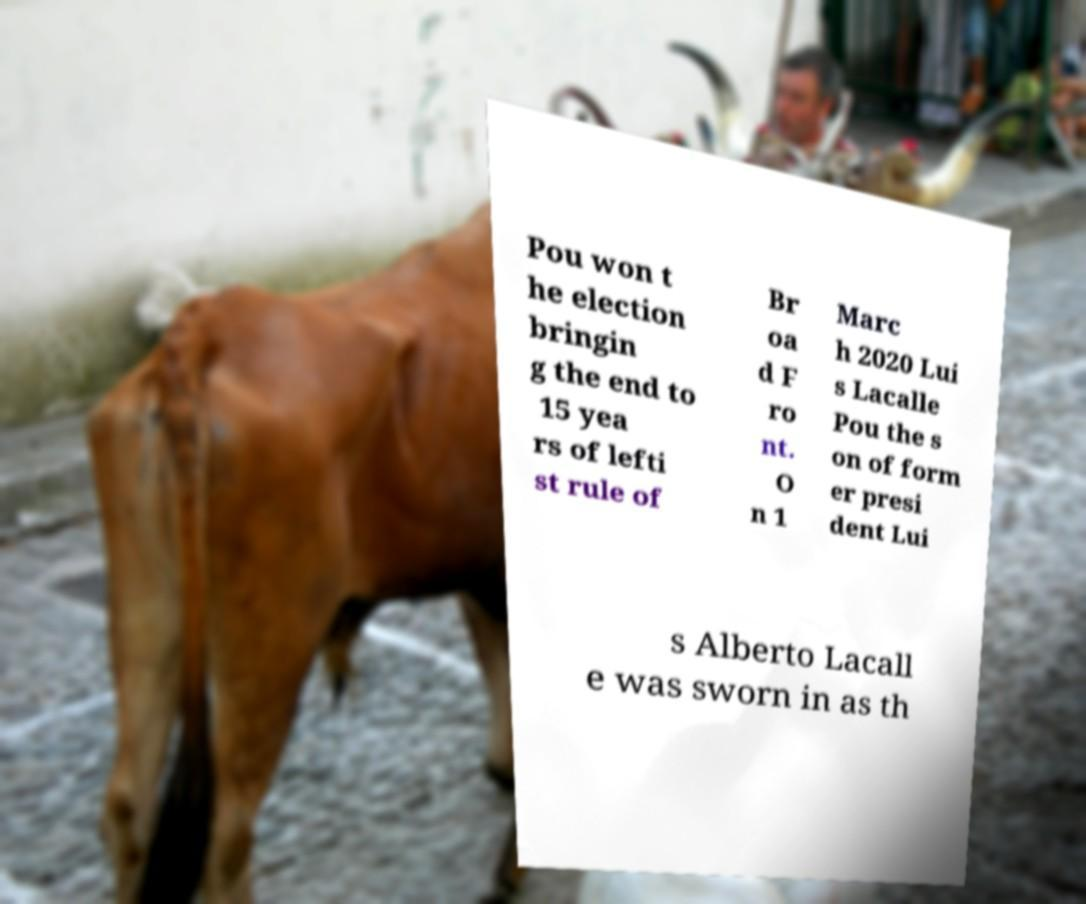There's text embedded in this image that I need extracted. Can you transcribe it verbatim? Pou won t he election bringin g the end to 15 yea rs of lefti st rule of Br oa d F ro nt. O n 1 Marc h 2020 Lui s Lacalle Pou the s on of form er presi dent Lui s Alberto Lacall e was sworn in as th 